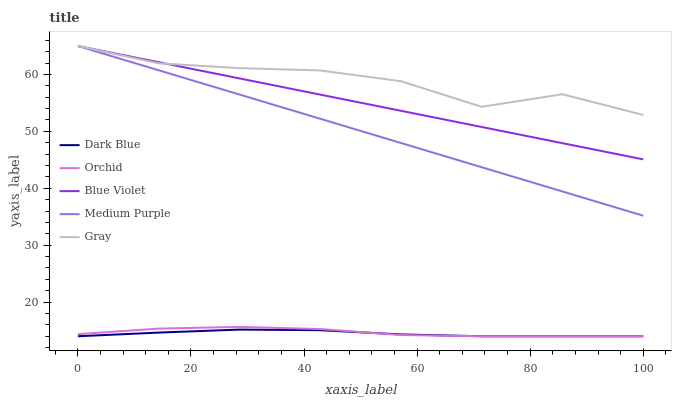Does Dark Blue have the minimum area under the curve?
Answer yes or no. Yes. Does Gray have the maximum area under the curve?
Answer yes or no. Yes. Does Gray have the minimum area under the curve?
Answer yes or no. No. Does Dark Blue have the maximum area under the curve?
Answer yes or no. No. Is Blue Violet the smoothest?
Answer yes or no. Yes. Is Gray the roughest?
Answer yes or no. Yes. Is Dark Blue the smoothest?
Answer yes or no. No. Is Dark Blue the roughest?
Answer yes or no. No. Does Gray have the lowest value?
Answer yes or no. No. Does Blue Violet have the highest value?
Answer yes or no. Yes. Does Dark Blue have the highest value?
Answer yes or no. No. Is Dark Blue less than Gray?
Answer yes or no. Yes. Is Medium Purple greater than Dark Blue?
Answer yes or no. Yes. Does Medium Purple intersect Blue Violet?
Answer yes or no. Yes. Is Medium Purple less than Blue Violet?
Answer yes or no. No. Is Medium Purple greater than Blue Violet?
Answer yes or no. No. Does Dark Blue intersect Gray?
Answer yes or no. No. 